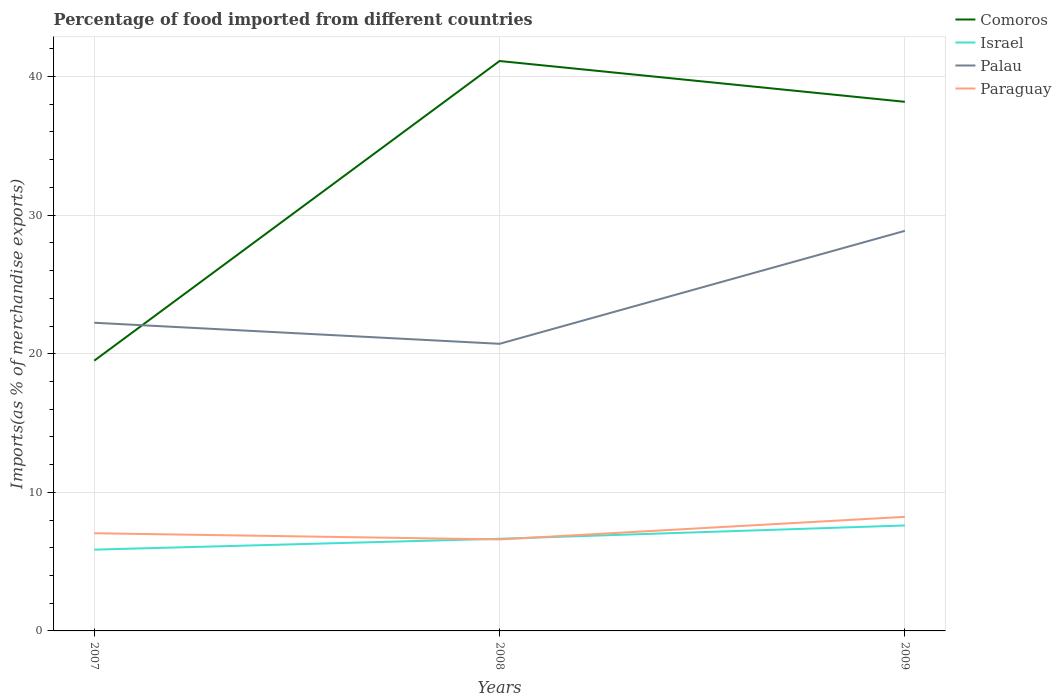How many different coloured lines are there?
Offer a very short reply. 4. Across all years, what is the maximum percentage of imports to different countries in Comoros?
Provide a succinct answer. 19.5. What is the total percentage of imports to different countries in Palau in the graph?
Give a very brief answer. -8.15. What is the difference between the highest and the second highest percentage of imports to different countries in Palau?
Your answer should be compact. 8.15. How many years are there in the graph?
Provide a succinct answer. 3. What is the difference between two consecutive major ticks on the Y-axis?
Ensure brevity in your answer.  10. Does the graph contain any zero values?
Give a very brief answer. No. Does the graph contain grids?
Offer a very short reply. Yes. Where does the legend appear in the graph?
Ensure brevity in your answer.  Top right. How many legend labels are there?
Provide a succinct answer. 4. What is the title of the graph?
Offer a very short reply. Percentage of food imported from different countries. Does "Austria" appear as one of the legend labels in the graph?
Your answer should be compact. No. What is the label or title of the X-axis?
Keep it short and to the point. Years. What is the label or title of the Y-axis?
Provide a succinct answer. Imports(as % of merchandise exports). What is the Imports(as % of merchandise exports) in Comoros in 2007?
Keep it short and to the point. 19.5. What is the Imports(as % of merchandise exports) in Israel in 2007?
Give a very brief answer. 5.86. What is the Imports(as % of merchandise exports) of Palau in 2007?
Your answer should be compact. 22.24. What is the Imports(as % of merchandise exports) in Paraguay in 2007?
Keep it short and to the point. 7.05. What is the Imports(as % of merchandise exports) in Comoros in 2008?
Keep it short and to the point. 41.12. What is the Imports(as % of merchandise exports) in Israel in 2008?
Keep it short and to the point. 6.65. What is the Imports(as % of merchandise exports) in Palau in 2008?
Provide a short and direct response. 20.72. What is the Imports(as % of merchandise exports) in Paraguay in 2008?
Your answer should be compact. 6.6. What is the Imports(as % of merchandise exports) of Comoros in 2009?
Provide a succinct answer. 38.18. What is the Imports(as % of merchandise exports) of Israel in 2009?
Your response must be concise. 7.61. What is the Imports(as % of merchandise exports) in Palau in 2009?
Provide a short and direct response. 28.87. What is the Imports(as % of merchandise exports) in Paraguay in 2009?
Offer a terse response. 8.23. Across all years, what is the maximum Imports(as % of merchandise exports) of Comoros?
Ensure brevity in your answer.  41.12. Across all years, what is the maximum Imports(as % of merchandise exports) in Israel?
Your answer should be compact. 7.61. Across all years, what is the maximum Imports(as % of merchandise exports) in Palau?
Ensure brevity in your answer.  28.87. Across all years, what is the maximum Imports(as % of merchandise exports) in Paraguay?
Offer a very short reply. 8.23. Across all years, what is the minimum Imports(as % of merchandise exports) of Comoros?
Offer a terse response. 19.5. Across all years, what is the minimum Imports(as % of merchandise exports) in Israel?
Provide a short and direct response. 5.86. Across all years, what is the minimum Imports(as % of merchandise exports) of Palau?
Your answer should be very brief. 20.72. Across all years, what is the minimum Imports(as % of merchandise exports) in Paraguay?
Give a very brief answer. 6.6. What is the total Imports(as % of merchandise exports) in Comoros in the graph?
Ensure brevity in your answer.  98.8. What is the total Imports(as % of merchandise exports) of Israel in the graph?
Your answer should be compact. 20.12. What is the total Imports(as % of merchandise exports) in Palau in the graph?
Ensure brevity in your answer.  71.82. What is the total Imports(as % of merchandise exports) of Paraguay in the graph?
Provide a short and direct response. 21.88. What is the difference between the Imports(as % of merchandise exports) of Comoros in 2007 and that in 2008?
Your answer should be very brief. -21.62. What is the difference between the Imports(as % of merchandise exports) of Israel in 2007 and that in 2008?
Ensure brevity in your answer.  -0.78. What is the difference between the Imports(as % of merchandise exports) in Palau in 2007 and that in 2008?
Offer a terse response. 1.52. What is the difference between the Imports(as % of merchandise exports) of Paraguay in 2007 and that in 2008?
Keep it short and to the point. 0.45. What is the difference between the Imports(as % of merchandise exports) in Comoros in 2007 and that in 2009?
Your response must be concise. -18.68. What is the difference between the Imports(as % of merchandise exports) in Israel in 2007 and that in 2009?
Make the answer very short. -1.74. What is the difference between the Imports(as % of merchandise exports) of Palau in 2007 and that in 2009?
Keep it short and to the point. -6.63. What is the difference between the Imports(as % of merchandise exports) of Paraguay in 2007 and that in 2009?
Your answer should be very brief. -1.18. What is the difference between the Imports(as % of merchandise exports) in Comoros in 2008 and that in 2009?
Offer a very short reply. 2.94. What is the difference between the Imports(as % of merchandise exports) in Israel in 2008 and that in 2009?
Ensure brevity in your answer.  -0.96. What is the difference between the Imports(as % of merchandise exports) in Palau in 2008 and that in 2009?
Your answer should be very brief. -8.15. What is the difference between the Imports(as % of merchandise exports) of Paraguay in 2008 and that in 2009?
Offer a terse response. -1.63. What is the difference between the Imports(as % of merchandise exports) of Comoros in 2007 and the Imports(as % of merchandise exports) of Israel in 2008?
Make the answer very short. 12.85. What is the difference between the Imports(as % of merchandise exports) of Comoros in 2007 and the Imports(as % of merchandise exports) of Palau in 2008?
Provide a succinct answer. -1.22. What is the difference between the Imports(as % of merchandise exports) in Comoros in 2007 and the Imports(as % of merchandise exports) in Paraguay in 2008?
Offer a terse response. 12.9. What is the difference between the Imports(as % of merchandise exports) in Israel in 2007 and the Imports(as % of merchandise exports) in Palau in 2008?
Your answer should be very brief. -14.85. What is the difference between the Imports(as % of merchandise exports) in Israel in 2007 and the Imports(as % of merchandise exports) in Paraguay in 2008?
Your response must be concise. -0.74. What is the difference between the Imports(as % of merchandise exports) in Palau in 2007 and the Imports(as % of merchandise exports) in Paraguay in 2008?
Provide a short and direct response. 15.63. What is the difference between the Imports(as % of merchandise exports) of Comoros in 2007 and the Imports(as % of merchandise exports) of Israel in 2009?
Provide a succinct answer. 11.89. What is the difference between the Imports(as % of merchandise exports) of Comoros in 2007 and the Imports(as % of merchandise exports) of Palau in 2009?
Keep it short and to the point. -9.37. What is the difference between the Imports(as % of merchandise exports) of Comoros in 2007 and the Imports(as % of merchandise exports) of Paraguay in 2009?
Provide a short and direct response. 11.27. What is the difference between the Imports(as % of merchandise exports) in Israel in 2007 and the Imports(as % of merchandise exports) in Palau in 2009?
Your answer should be very brief. -23. What is the difference between the Imports(as % of merchandise exports) in Israel in 2007 and the Imports(as % of merchandise exports) in Paraguay in 2009?
Keep it short and to the point. -2.37. What is the difference between the Imports(as % of merchandise exports) of Palau in 2007 and the Imports(as % of merchandise exports) of Paraguay in 2009?
Ensure brevity in your answer.  14. What is the difference between the Imports(as % of merchandise exports) in Comoros in 2008 and the Imports(as % of merchandise exports) in Israel in 2009?
Your answer should be very brief. 33.51. What is the difference between the Imports(as % of merchandise exports) of Comoros in 2008 and the Imports(as % of merchandise exports) of Palau in 2009?
Provide a succinct answer. 12.25. What is the difference between the Imports(as % of merchandise exports) in Comoros in 2008 and the Imports(as % of merchandise exports) in Paraguay in 2009?
Provide a succinct answer. 32.89. What is the difference between the Imports(as % of merchandise exports) in Israel in 2008 and the Imports(as % of merchandise exports) in Palau in 2009?
Give a very brief answer. -22.22. What is the difference between the Imports(as % of merchandise exports) of Israel in 2008 and the Imports(as % of merchandise exports) of Paraguay in 2009?
Provide a succinct answer. -1.58. What is the difference between the Imports(as % of merchandise exports) in Palau in 2008 and the Imports(as % of merchandise exports) in Paraguay in 2009?
Provide a short and direct response. 12.48. What is the average Imports(as % of merchandise exports) in Comoros per year?
Offer a very short reply. 32.93. What is the average Imports(as % of merchandise exports) of Israel per year?
Provide a short and direct response. 6.71. What is the average Imports(as % of merchandise exports) in Palau per year?
Your answer should be compact. 23.94. What is the average Imports(as % of merchandise exports) in Paraguay per year?
Provide a succinct answer. 7.29. In the year 2007, what is the difference between the Imports(as % of merchandise exports) of Comoros and Imports(as % of merchandise exports) of Israel?
Give a very brief answer. 13.63. In the year 2007, what is the difference between the Imports(as % of merchandise exports) of Comoros and Imports(as % of merchandise exports) of Palau?
Offer a very short reply. -2.74. In the year 2007, what is the difference between the Imports(as % of merchandise exports) in Comoros and Imports(as % of merchandise exports) in Paraguay?
Offer a very short reply. 12.45. In the year 2007, what is the difference between the Imports(as % of merchandise exports) in Israel and Imports(as % of merchandise exports) in Palau?
Make the answer very short. -16.37. In the year 2007, what is the difference between the Imports(as % of merchandise exports) of Israel and Imports(as % of merchandise exports) of Paraguay?
Your answer should be very brief. -1.18. In the year 2007, what is the difference between the Imports(as % of merchandise exports) in Palau and Imports(as % of merchandise exports) in Paraguay?
Your answer should be compact. 15.19. In the year 2008, what is the difference between the Imports(as % of merchandise exports) in Comoros and Imports(as % of merchandise exports) in Israel?
Keep it short and to the point. 34.47. In the year 2008, what is the difference between the Imports(as % of merchandise exports) in Comoros and Imports(as % of merchandise exports) in Palau?
Offer a terse response. 20.4. In the year 2008, what is the difference between the Imports(as % of merchandise exports) in Comoros and Imports(as % of merchandise exports) in Paraguay?
Ensure brevity in your answer.  34.52. In the year 2008, what is the difference between the Imports(as % of merchandise exports) of Israel and Imports(as % of merchandise exports) of Palau?
Your answer should be compact. -14.07. In the year 2008, what is the difference between the Imports(as % of merchandise exports) in Israel and Imports(as % of merchandise exports) in Paraguay?
Keep it short and to the point. 0.05. In the year 2008, what is the difference between the Imports(as % of merchandise exports) in Palau and Imports(as % of merchandise exports) in Paraguay?
Ensure brevity in your answer.  14.12. In the year 2009, what is the difference between the Imports(as % of merchandise exports) in Comoros and Imports(as % of merchandise exports) in Israel?
Make the answer very short. 30.57. In the year 2009, what is the difference between the Imports(as % of merchandise exports) of Comoros and Imports(as % of merchandise exports) of Palau?
Keep it short and to the point. 9.31. In the year 2009, what is the difference between the Imports(as % of merchandise exports) of Comoros and Imports(as % of merchandise exports) of Paraguay?
Your answer should be compact. 29.94. In the year 2009, what is the difference between the Imports(as % of merchandise exports) of Israel and Imports(as % of merchandise exports) of Palau?
Your response must be concise. -21.26. In the year 2009, what is the difference between the Imports(as % of merchandise exports) of Israel and Imports(as % of merchandise exports) of Paraguay?
Offer a terse response. -0.62. In the year 2009, what is the difference between the Imports(as % of merchandise exports) in Palau and Imports(as % of merchandise exports) in Paraguay?
Offer a very short reply. 20.63. What is the ratio of the Imports(as % of merchandise exports) of Comoros in 2007 to that in 2008?
Provide a short and direct response. 0.47. What is the ratio of the Imports(as % of merchandise exports) of Israel in 2007 to that in 2008?
Provide a short and direct response. 0.88. What is the ratio of the Imports(as % of merchandise exports) in Palau in 2007 to that in 2008?
Offer a very short reply. 1.07. What is the ratio of the Imports(as % of merchandise exports) of Paraguay in 2007 to that in 2008?
Offer a very short reply. 1.07. What is the ratio of the Imports(as % of merchandise exports) of Comoros in 2007 to that in 2009?
Make the answer very short. 0.51. What is the ratio of the Imports(as % of merchandise exports) in Israel in 2007 to that in 2009?
Keep it short and to the point. 0.77. What is the ratio of the Imports(as % of merchandise exports) in Palau in 2007 to that in 2009?
Your response must be concise. 0.77. What is the ratio of the Imports(as % of merchandise exports) in Paraguay in 2007 to that in 2009?
Make the answer very short. 0.86. What is the ratio of the Imports(as % of merchandise exports) in Comoros in 2008 to that in 2009?
Provide a succinct answer. 1.08. What is the ratio of the Imports(as % of merchandise exports) in Israel in 2008 to that in 2009?
Make the answer very short. 0.87. What is the ratio of the Imports(as % of merchandise exports) of Palau in 2008 to that in 2009?
Your answer should be very brief. 0.72. What is the ratio of the Imports(as % of merchandise exports) in Paraguay in 2008 to that in 2009?
Offer a very short reply. 0.8. What is the difference between the highest and the second highest Imports(as % of merchandise exports) of Comoros?
Make the answer very short. 2.94. What is the difference between the highest and the second highest Imports(as % of merchandise exports) in Israel?
Make the answer very short. 0.96. What is the difference between the highest and the second highest Imports(as % of merchandise exports) in Palau?
Offer a terse response. 6.63. What is the difference between the highest and the second highest Imports(as % of merchandise exports) in Paraguay?
Offer a terse response. 1.18. What is the difference between the highest and the lowest Imports(as % of merchandise exports) in Comoros?
Offer a terse response. 21.62. What is the difference between the highest and the lowest Imports(as % of merchandise exports) of Israel?
Your answer should be very brief. 1.74. What is the difference between the highest and the lowest Imports(as % of merchandise exports) of Palau?
Make the answer very short. 8.15. What is the difference between the highest and the lowest Imports(as % of merchandise exports) in Paraguay?
Provide a short and direct response. 1.63. 